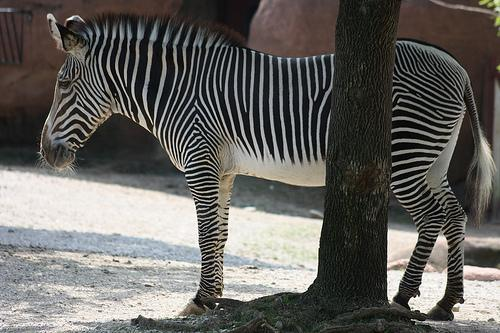Question: where is the zebra looking?
Choices:
A. At the ground.
B. At the tree.
C. To the left.
D. To the right.
Answer with the letter. Answer: C Question: what color are the zebra's eyes?
Choices:
A. Blue.
B. Black.
C. Red.
D. Pink.
Answer with the letter. Answer: B Question: how many animals are there?
Choices:
A. 2.
B. 1.
C. 3.
D. 6.
Answer with the letter. Answer: B Question: what is the zebra eating?
Choices:
A. Grass.
B. Weeds.
C. Nothing.
D. Leaves.
Answer with the letter. Answer: C Question: how many legs does the zebra have?
Choices:
A. 5.
B. 6.
C. 4.
D. 8.
Answer with the letter. Answer: C Question: what is in front of the zebra?
Choices:
A. Trees.
B. Grass.
C. A tree.
D. Brush.
Answer with the letter. Answer: C 